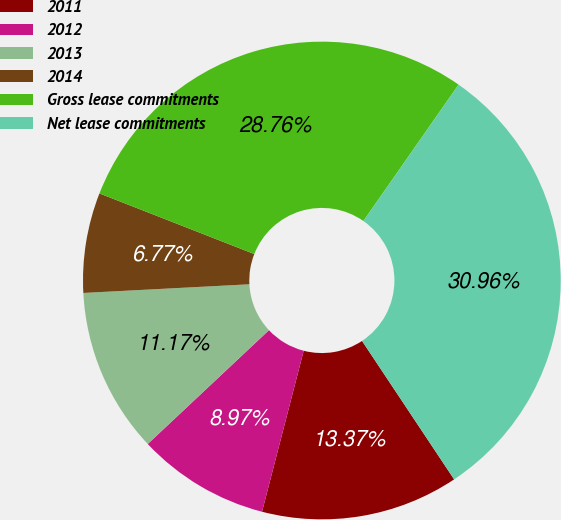Convert chart. <chart><loc_0><loc_0><loc_500><loc_500><pie_chart><fcel>2011<fcel>2012<fcel>2013<fcel>2014<fcel>Gross lease commitments<fcel>Net lease commitments<nl><fcel>13.37%<fcel>8.97%<fcel>11.17%<fcel>6.77%<fcel>28.76%<fcel>30.96%<nl></chart> 